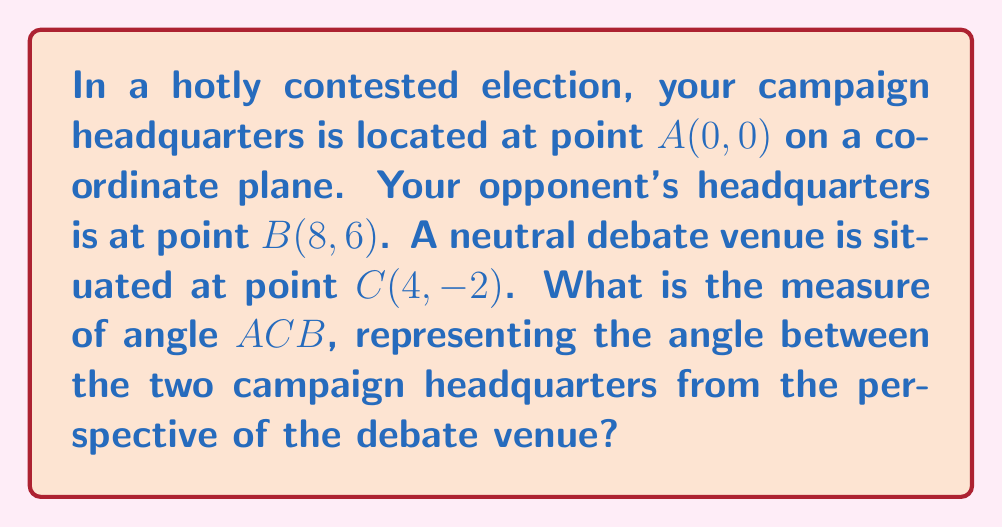Provide a solution to this math problem. To solve this problem, we'll use the following steps:

1) First, we need to calculate the lengths of the sides of triangle ABC using the distance formula:
   $d = \sqrt{(x_2-x_1)^2 + (y_2-y_1)^2}$

2) For AC:
   $AC = \sqrt{(4-0)^2 + (-2-0)^2} = \sqrt{16 + 4} = \sqrt{20} = 2\sqrt{5}$

3) For BC:
   $BC = \sqrt{(4-8)^2 + (-2-6)^2} = \sqrt{16 + 64} = \sqrt{80} = 4\sqrt{5}$

4) For AB:
   $AB = \sqrt{(8-0)^2 + (6-0)^2} = \sqrt{64 + 36} = \sqrt{100} = 10$

5) Now we can use the cosine law to find angle ACB:
   $\cos(ACB) = \frac{AC^2 + BC^2 - AB^2}{2(AC)(BC)}$

6) Substituting our values:
   $\cos(ACB) = \frac{(2\sqrt{5})^2 + (4\sqrt{5})^2 - 10^2}{2(2\sqrt{5})(4\sqrt{5})}$

7) Simplifying:
   $\cos(ACB) = \frac{20 + 80 - 100}{16\sqrt{5}\sqrt{5}} = \frac{0}{80} = 0$

8) Therefore:
   $ACB = \arccos(0) = 90°$

This result makes geometric sense, as it indicates that the debate venue forms a right angle with the two campaign headquarters, placing it equidistant from both in terms of political optics.
Answer: 90° 